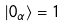<formula> <loc_0><loc_0><loc_500><loc_500>| 0 _ { \alpha } \rangle = 1</formula> 